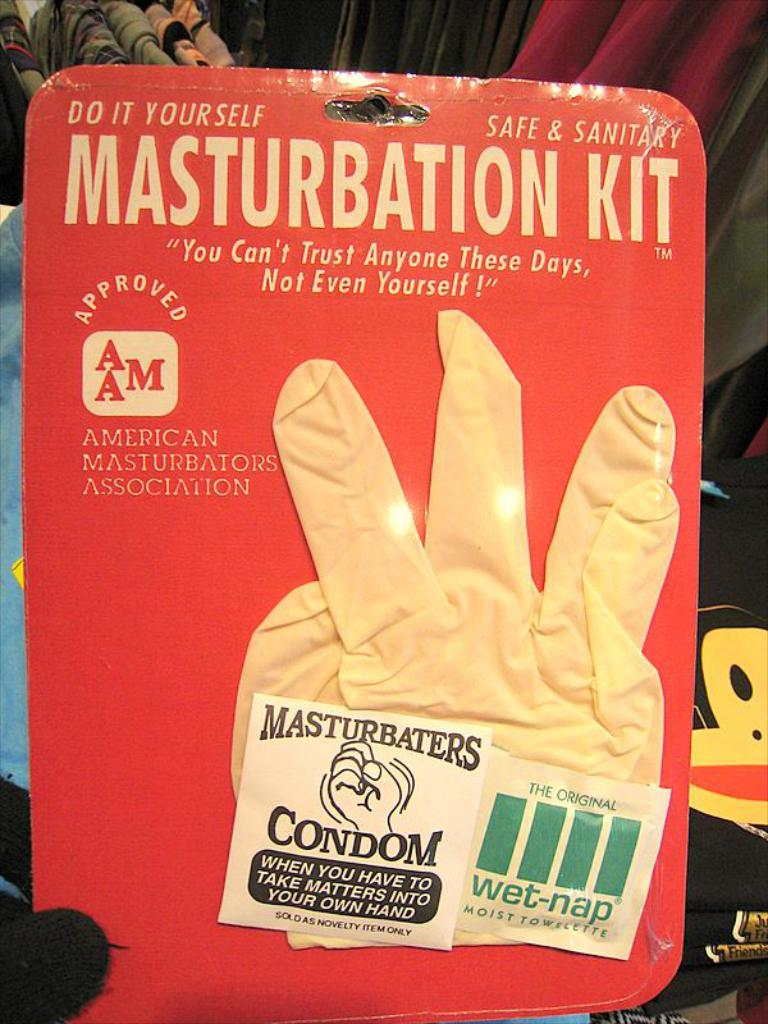<image>
Give a short and clear explanation of the subsequent image. A comical product called the Masturbation Kit contains a rubber glove, a condom and a packet of wet wipes. 